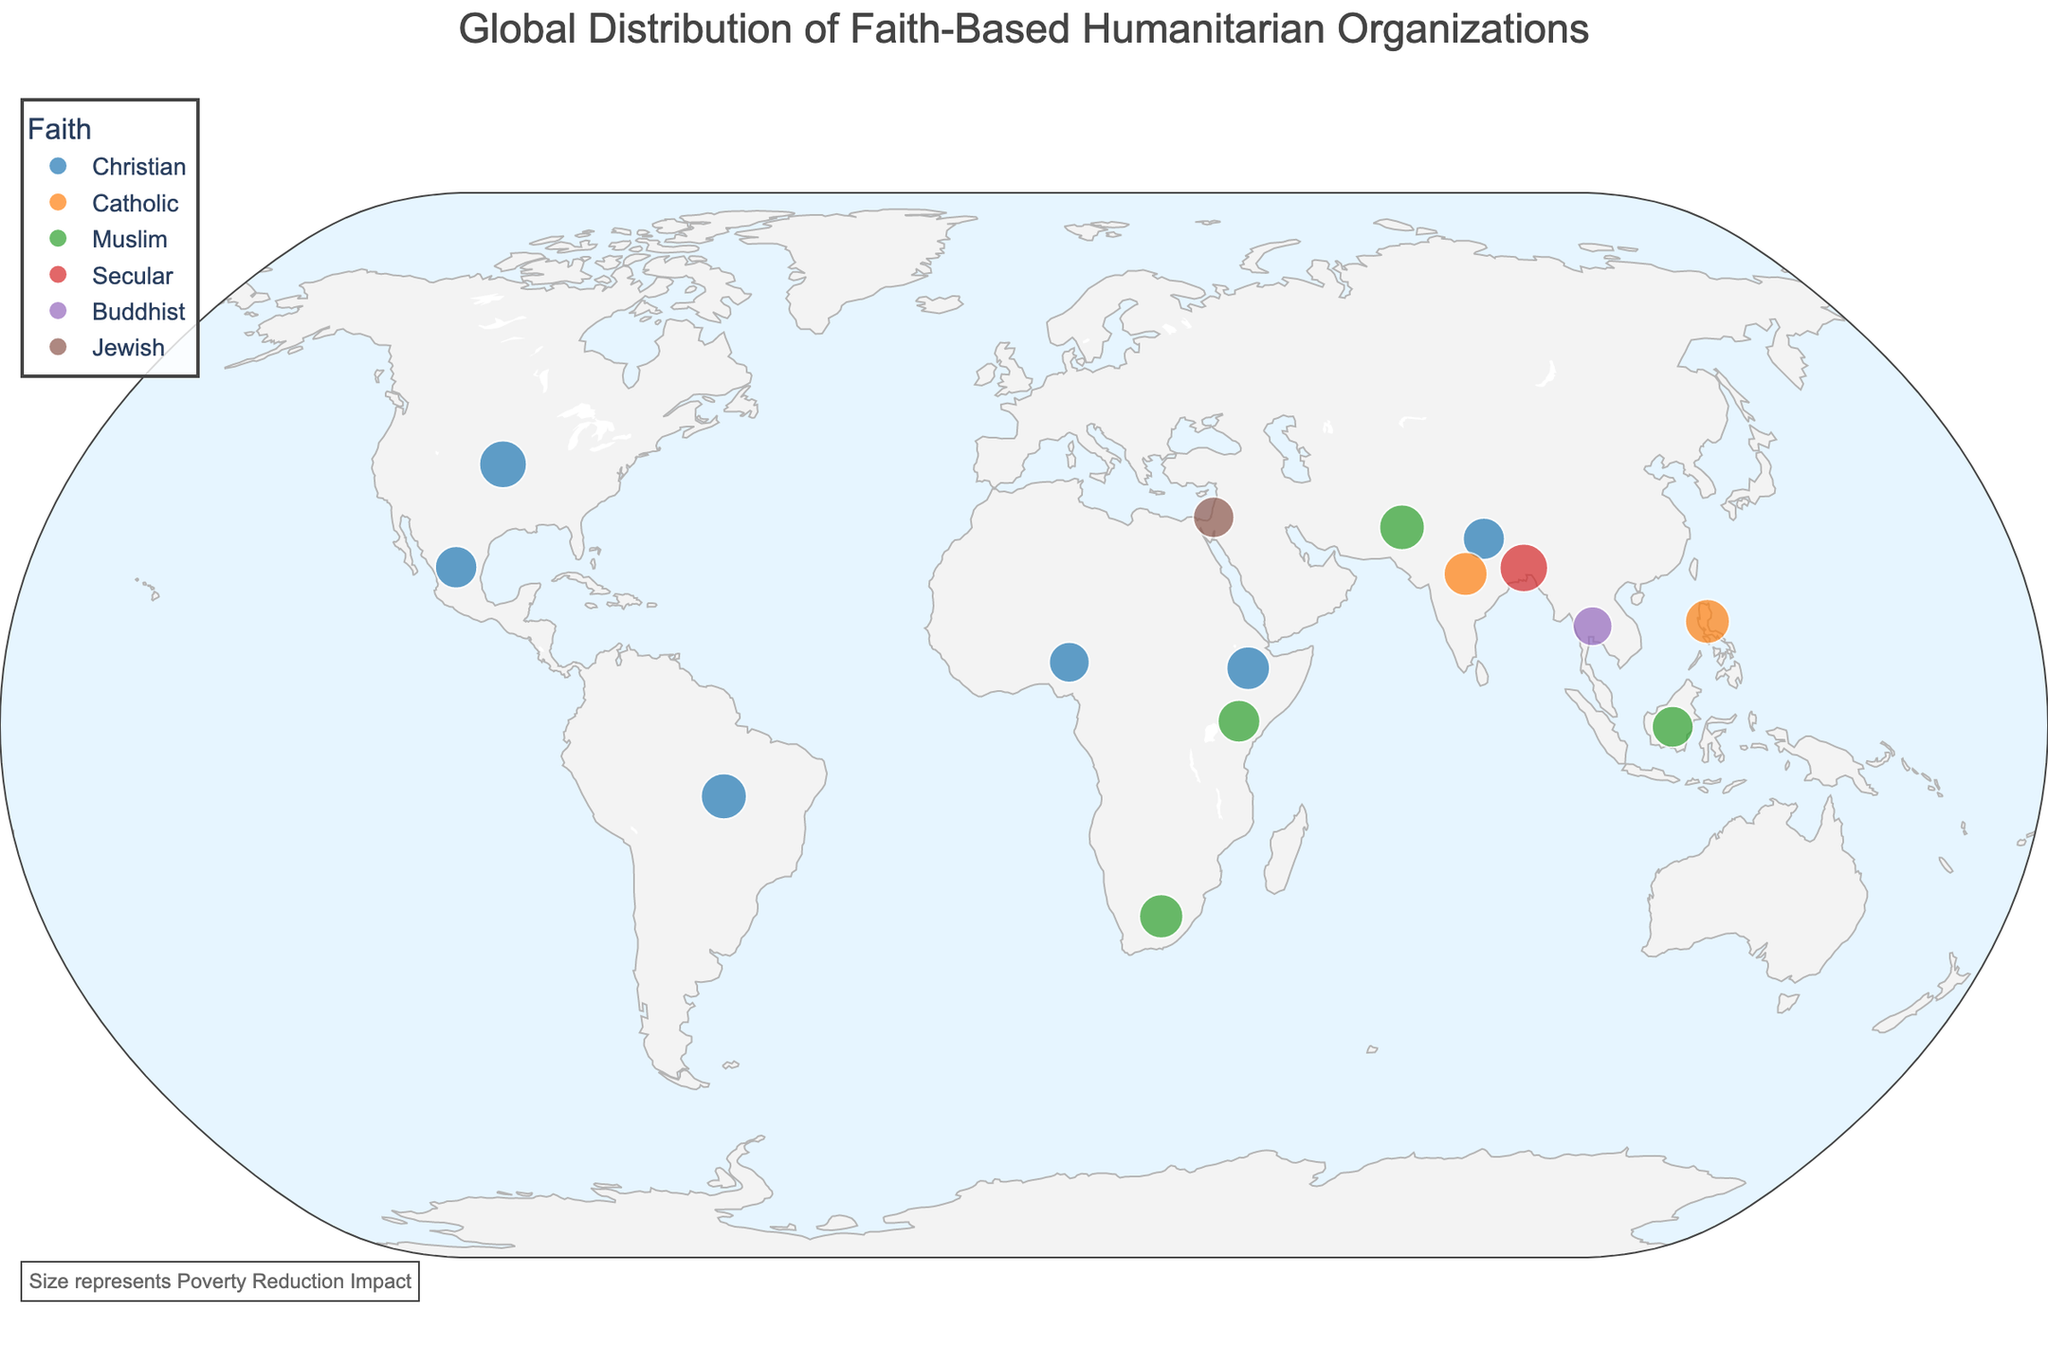What's the title of the figure? The figure title is prominently displayed at the top, centered within the layout.
Answer: Global Distribution of Faith-Based Humanitarian Organizations How many faith-based groups are represented in the plot? There are different color markers for each faith group in the legend: Christian, Catholic, Muslim, Secular, Buddhist, and Jewish. Count all unique faith categories.
Answer: 6 Which country has the highest Poverty Reduction Impact? Look for the largest-sized marker in the figure, as size represents Poverty Reduction Impact. The legend further clarifies this relationship.
Answer: Bangladesh Which faith-based organization in Africa has the highest number of volunteers? Identify the African countries on the map and check the hover data for the number of volunteers.
Answer: Gift of the Givers in South Africa Compare the Poverty Reduction Impact between India and Brazil. Which country has a higher impact? Locate India and Brazil on the map and compare the sizes of their markers, which correspond to Poverty Reduction Impact.
Answer: Brazil What is the average Poverty Reduction Impact of Christian organizations? Identify all Christian organizations (United States, Brazil, Nigeria, Ethiopia, Mexico, Nepal) and calculate the average of their Poverty Reduction Impact values.
Answer: (8.5 + 7.9 + 6.2 + 7.1 + 6.7 + 6.6) / 6 = 7.17 Which organization's marker color represents the Catholic faith? The legend matching color to faith reveals the Catholic-related markers' color, then identify any organization with that color marker.
Answer: Catholic Relief Services (orange color) Are there more volunteers in faith-based humanitarian organizations in the United States or Indonesia? Check the hover data or refer to the data points for both countries and compare the Volunteers values.
Answer: United States What is the Poverty Reduction Impact difference between the Edhi Foundation and Buddhist Global Relief? Identify each organization's marker and check their sizes or hover data. Calculate the difference between their Poverty Reduction Impact values.
Answer: 7.8 - 5.9 = 1.9 Identify the faith and Poverty Reduction Impact of the organization located in Kenya. Locate Kenya on the map and check the marker's hover data to determine the faith and Poverty Reduction Impact.
Answer: Muslim, 6.8 